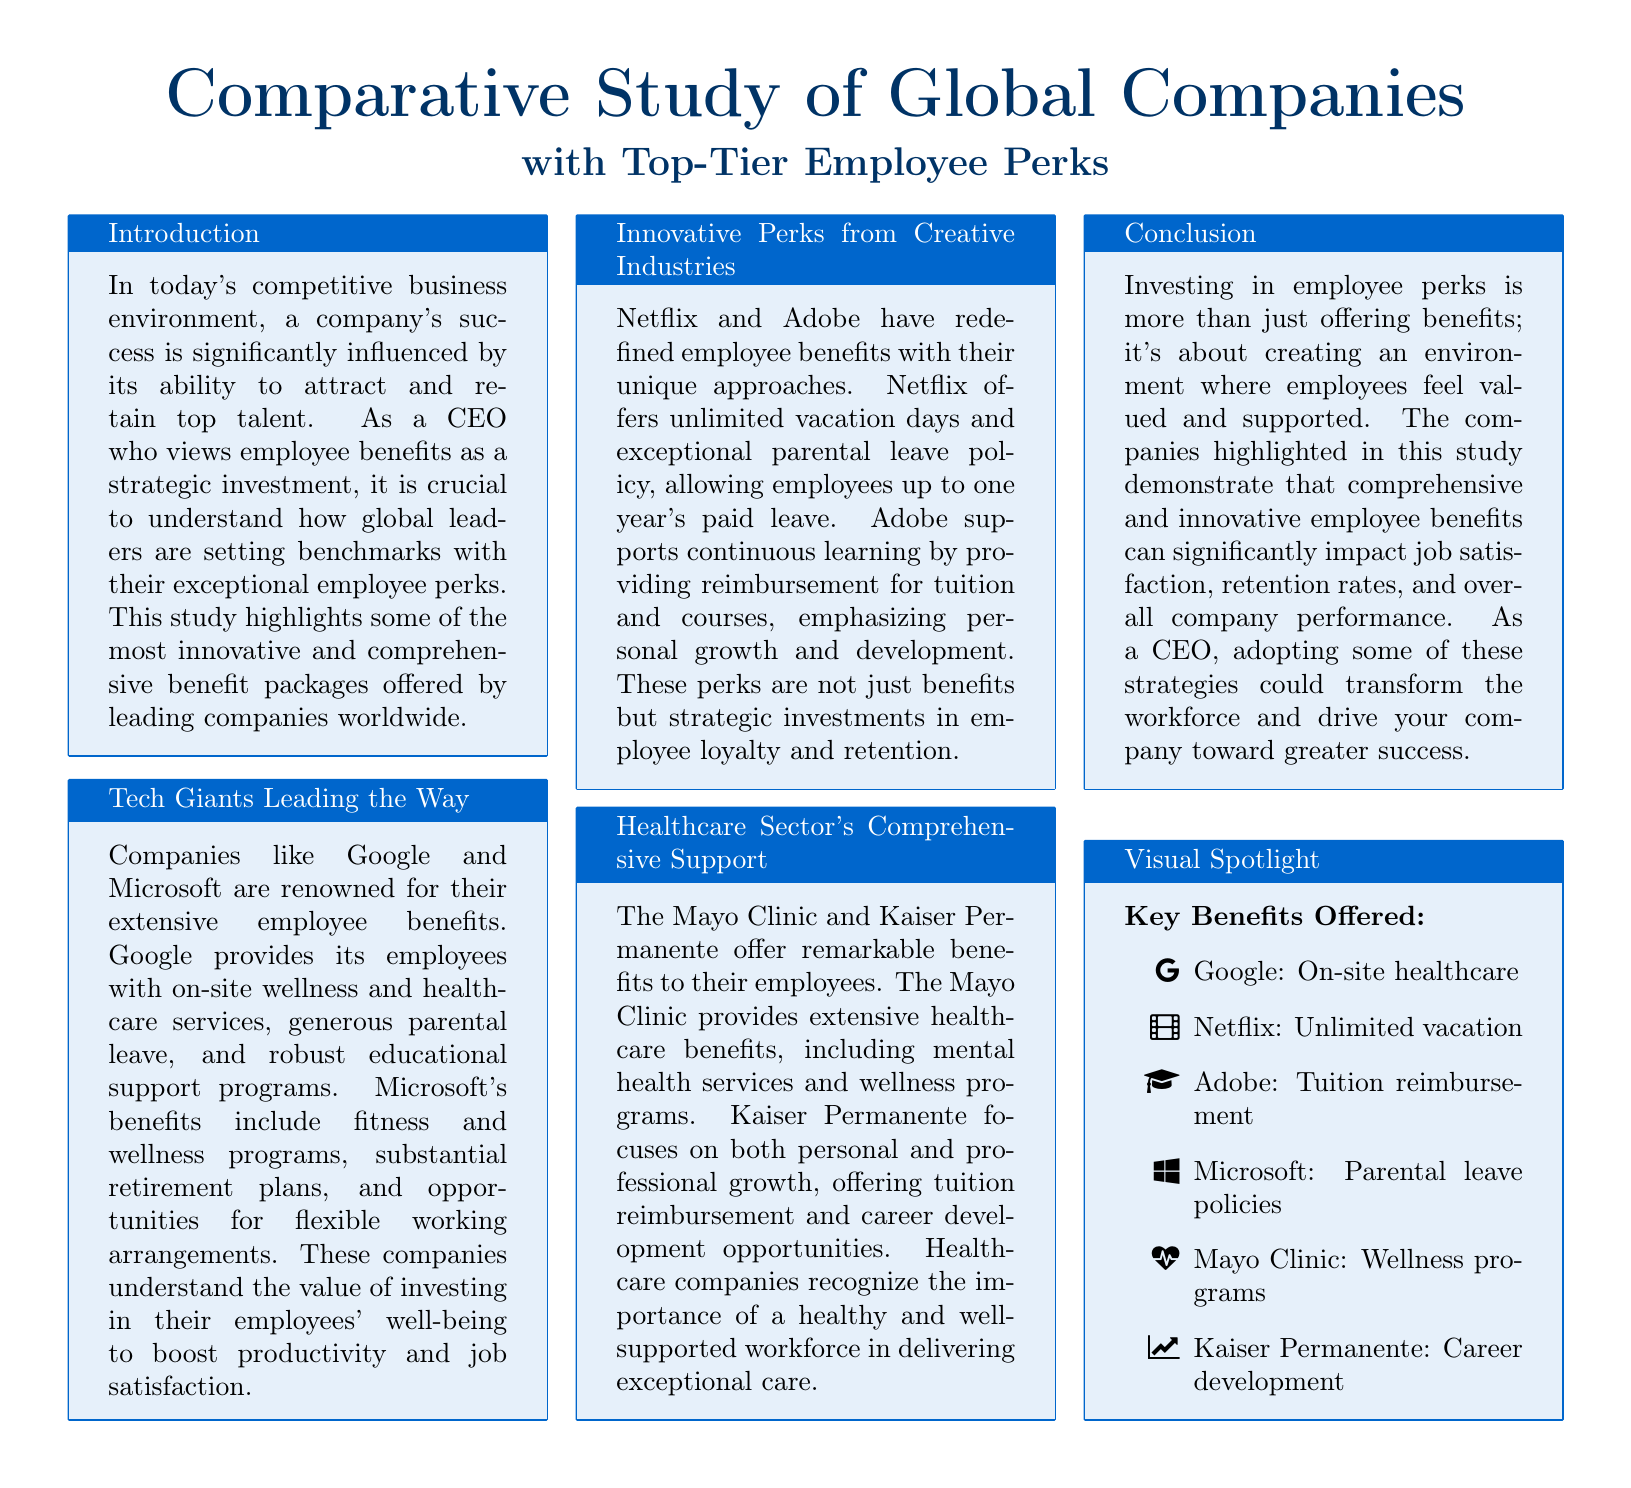What benefits does Google provide? Google provides on-site wellness and healthcare services, generous parental leave, and robust educational support programs.
Answer: On-site healthcare What unique perk does Netflix offer? Netflix offers unlimited vacation days and has an exceptional parental leave policy allowing employees up to one year's paid leave.
Answer: Unlimited vacation Which employee benefit is highlighted for Adobe? Adobe supports continuous learning by providing reimbursement for tuition and courses.
Answer: Tuition reimbursement What type of wellness programs does the Mayo Clinic offer? The Mayo Clinic provides extensive healthcare benefits, including mental health services and wellness programs.
Answer: Wellness programs What is the focus of Kaiser Permanente's employee benefits? Kaiser Permanente focuses on both personal and professional growth, offering tuition reimbursement and career development opportunities.
Answer: Career development What is the overall conclusion regarding employee perks? Investing in employee perks is about creating an environment where employees feel valued and supported, impacting job satisfaction and company performance.
Answer: Creating an environment How do tech giants like Google and Microsoft perceive employee benefits? These companies understand the value of investing in their employees' well-being to boost productivity and job satisfaction.
Answer: Strategic investment What visual elements are included in the study? The visual spotlight section lists key benefits offered by different companies with icons.
Answer: Key benefits Which sector is mentioned for its comprehensive support? The healthcare sector is highlighted for its comprehensive support for employees.
Answer: Healthcare sector 